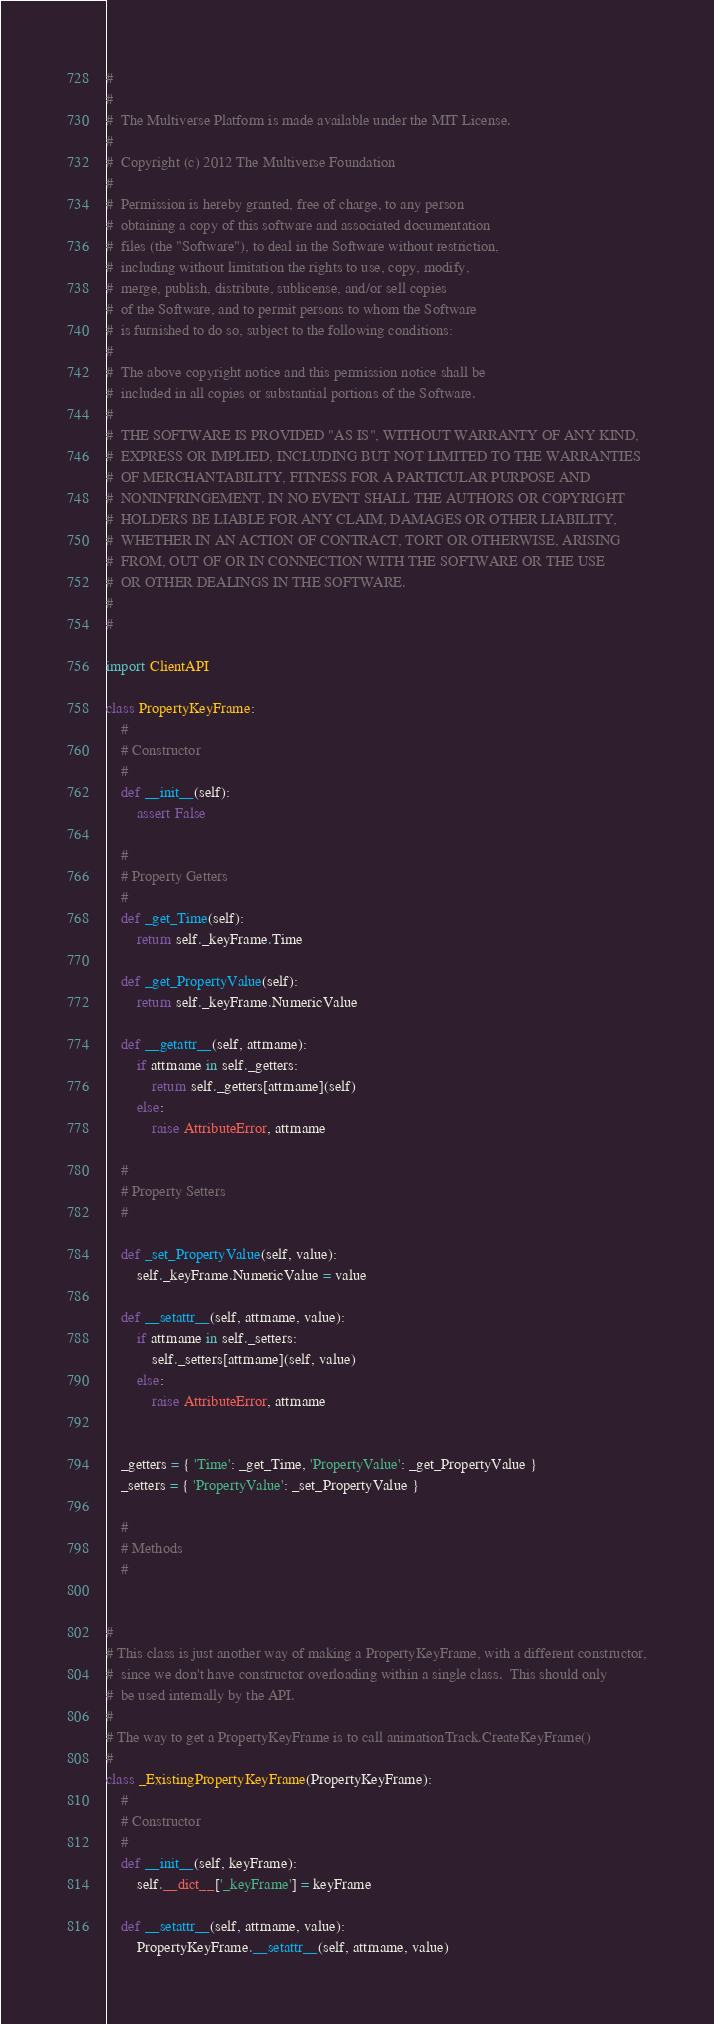Convert code to text. <code><loc_0><loc_0><loc_500><loc_500><_Python_>#
#
#  The Multiverse Platform is made available under the MIT License.
#
#  Copyright (c) 2012 The Multiverse Foundation
#
#  Permission is hereby granted, free of charge, to any person 
#  obtaining a copy of this software and associated documentation 
#  files (the "Software"), to deal in the Software without restriction, 
#  including without limitation the rights to use, copy, modify, 
#  merge, publish, distribute, sublicense, and/or sell copies 
#  of the Software, and to permit persons to whom the Software 
#  is furnished to do so, subject to the following conditions:
#
#  The above copyright notice and this permission notice shall be 
#  included in all copies or substantial portions of the Software.
#
#  THE SOFTWARE IS PROVIDED "AS IS", WITHOUT WARRANTY OF ANY KIND, 
#  EXPRESS OR IMPLIED, INCLUDING BUT NOT LIMITED TO THE WARRANTIES 
#  OF MERCHANTABILITY, FITNESS FOR A PARTICULAR PURPOSE AND 
#  NONINFRINGEMENT. IN NO EVENT SHALL THE AUTHORS OR COPYRIGHT 
#  HOLDERS BE LIABLE FOR ANY CLAIM, DAMAGES OR OTHER LIABILITY, 
#  WHETHER IN AN ACTION OF CONTRACT, TORT OR OTHERWISE, ARISING 
#  FROM, OUT OF OR IN CONNECTION WITH THE SOFTWARE OR THE USE 
#  OR OTHER DEALINGS IN THE SOFTWARE.
#
#  

import ClientAPI

class PropertyKeyFrame:
    #
    # Constructor
    #
    def __init__(self):
        assert False
        
    #
    # Property Getters
    #
    def _get_Time(self):
        return self._keyFrame.Time
        
    def _get_PropertyValue(self):
        return self._keyFrame.NumericValue
        
    def __getattr__(self, attrname):
        if attrname in self._getters:
            return self._getters[attrname](self)
        else:
            raise AttributeError, attrname

    #
    # Property Setters
    #

    def _set_PropertyValue(self, value):
        self._keyFrame.NumericValue = value
                
    def __setattr__(self, attrname, value):
        if attrname in self._setters:
            self._setters[attrname](self, value)
        else:
            raise AttributeError, attrname

            
    _getters = { 'Time': _get_Time, 'PropertyValue': _get_PropertyValue }
    _setters = { 'PropertyValue': _set_PropertyValue }
    
    #
    # Methods
    #

    
#
# This class is just another way of making a PropertyKeyFrame, with a different constructor,
#  since we don't have constructor overloading within a single class.  This should only
#  be used internally by the API.
#
# The way to get a PropertyKeyFrame is to call animationTrack.CreateKeyFrame()
#
class _ExistingPropertyKeyFrame(PropertyKeyFrame):
    #
    # Constructor
    #
    def __init__(self, keyFrame):
        self.__dict__['_keyFrame'] = keyFrame

    def __setattr__(self, attrname, value):
        PropertyKeyFrame.__setattr__(self, attrname, value)
</code> 